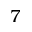Convert formula to latex. <formula><loc_0><loc_0><loc_500><loc_500>7</formula> 